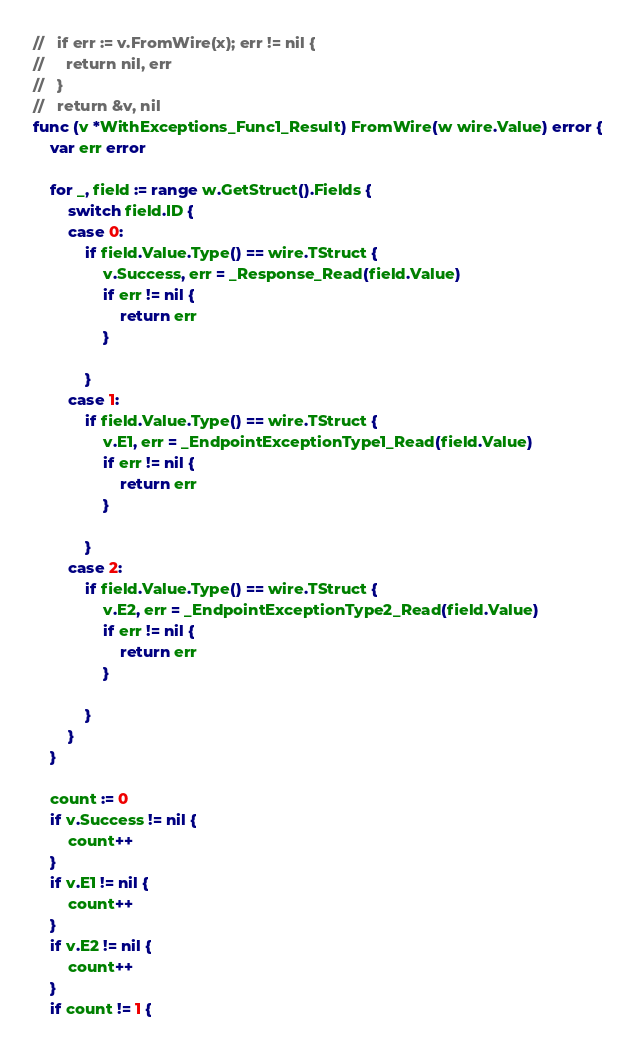Convert code to text. <code><loc_0><loc_0><loc_500><loc_500><_Go_>//   if err := v.FromWire(x); err != nil {
//     return nil, err
//   }
//   return &v, nil
func (v *WithExceptions_Func1_Result) FromWire(w wire.Value) error {
	var err error

	for _, field := range w.GetStruct().Fields {
		switch field.ID {
		case 0:
			if field.Value.Type() == wire.TStruct {
				v.Success, err = _Response_Read(field.Value)
				if err != nil {
					return err
				}

			}
		case 1:
			if field.Value.Type() == wire.TStruct {
				v.E1, err = _EndpointExceptionType1_Read(field.Value)
				if err != nil {
					return err
				}

			}
		case 2:
			if field.Value.Type() == wire.TStruct {
				v.E2, err = _EndpointExceptionType2_Read(field.Value)
				if err != nil {
					return err
				}

			}
		}
	}

	count := 0
	if v.Success != nil {
		count++
	}
	if v.E1 != nil {
		count++
	}
	if v.E2 != nil {
		count++
	}
	if count != 1 {</code> 